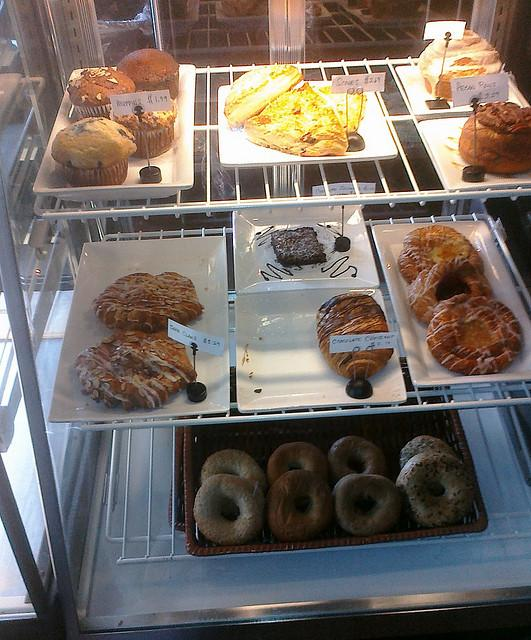What type of Danish is in the middle of the other two? Please explain your reasoning. blueberry. There is a danish with dark blue jelly in between the other two. 